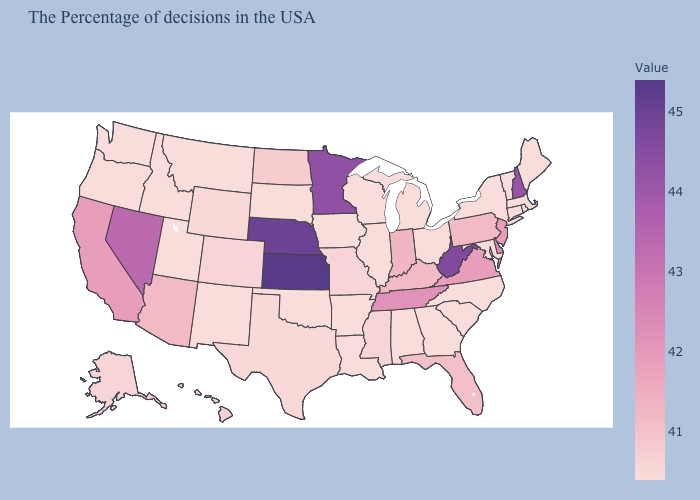Does Kansas have the highest value in the USA?
Write a very short answer. Yes. Among the states that border Oklahoma , does Kansas have the highest value?
Keep it brief. Yes. Which states have the lowest value in the USA?
Give a very brief answer. Maine, Massachusetts, Rhode Island, Vermont, Connecticut, New York, Maryland, North Carolina, South Carolina, Ohio, Georgia, Michigan, Alabama, Wisconsin, Illinois, Louisiana, Arkansas, Iowa, Oklahoma, South Dakota, New Mexico, Utah, Montana, Idaho, Washington, Oregon. Does Ohio have a lower value than Kansas?
Give a very brief answer. Yes. Does Kansas have the highest value in the MidWest?
Give a very brief answer. Yes. Among the states that border New Hampshire , which have the highest value?
Give a very brief answer. Maine, Massachusetts, Vermont. Which states have the lowest value in the West?
Be succinct. New Mexico, Utah, Montana, Idaho, Washington, Oregon. Which states hav the highest value in the MidWest?
Concise answer only. Kansas. 